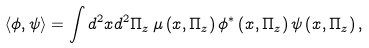<formula> <loc_0><loc_0><loc_500><loc_500>\langle \phi , \psi \rangle = \int d ^ { 2 } x d ^ { 2 } \Pi _ { z } \, \mu \left ( x , \Pi _ { z } \right ) \phi ^ { \ast } \left ( x , \Pi _ { z } \right ) \psi \left ( x , \Pi _ { z } \right ) ,</formula> 